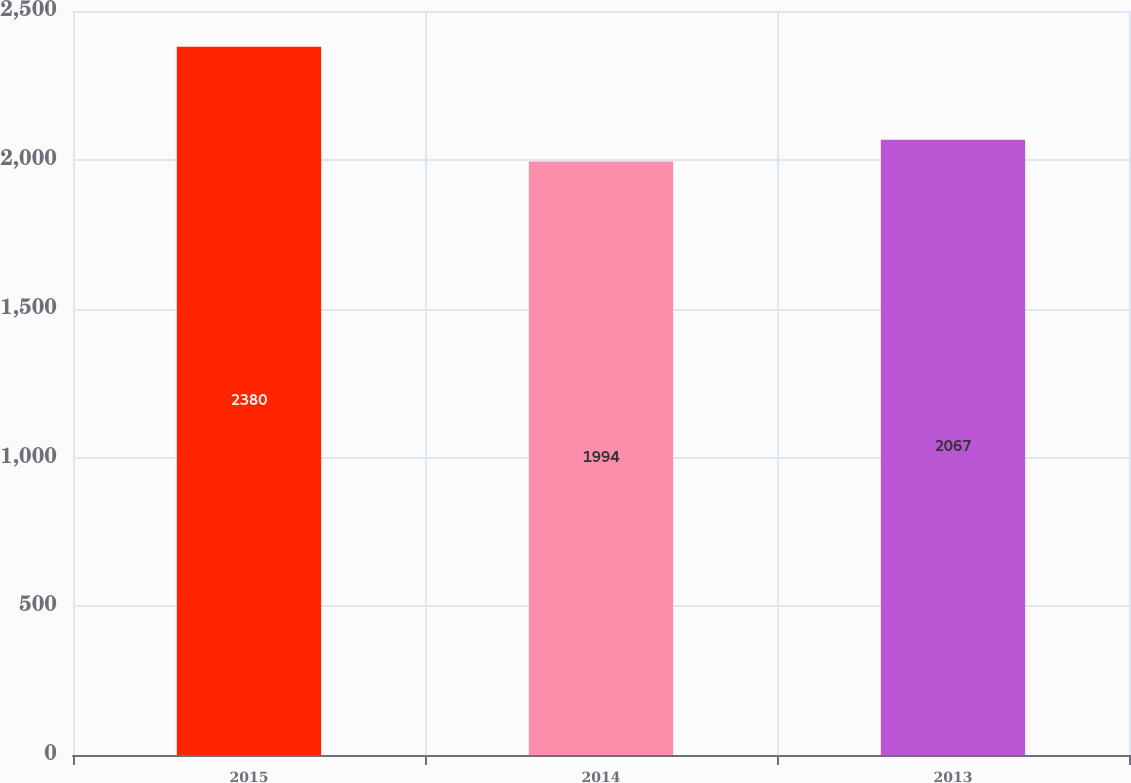Convert chart. <chart><loc_0><loc_0><loc_500><loc_500><bar_chart><fcel>2015<fcel>2014<fcel>2013<nl><fcel>2380<fcel>1994<fcel>2067<nl></chart> 